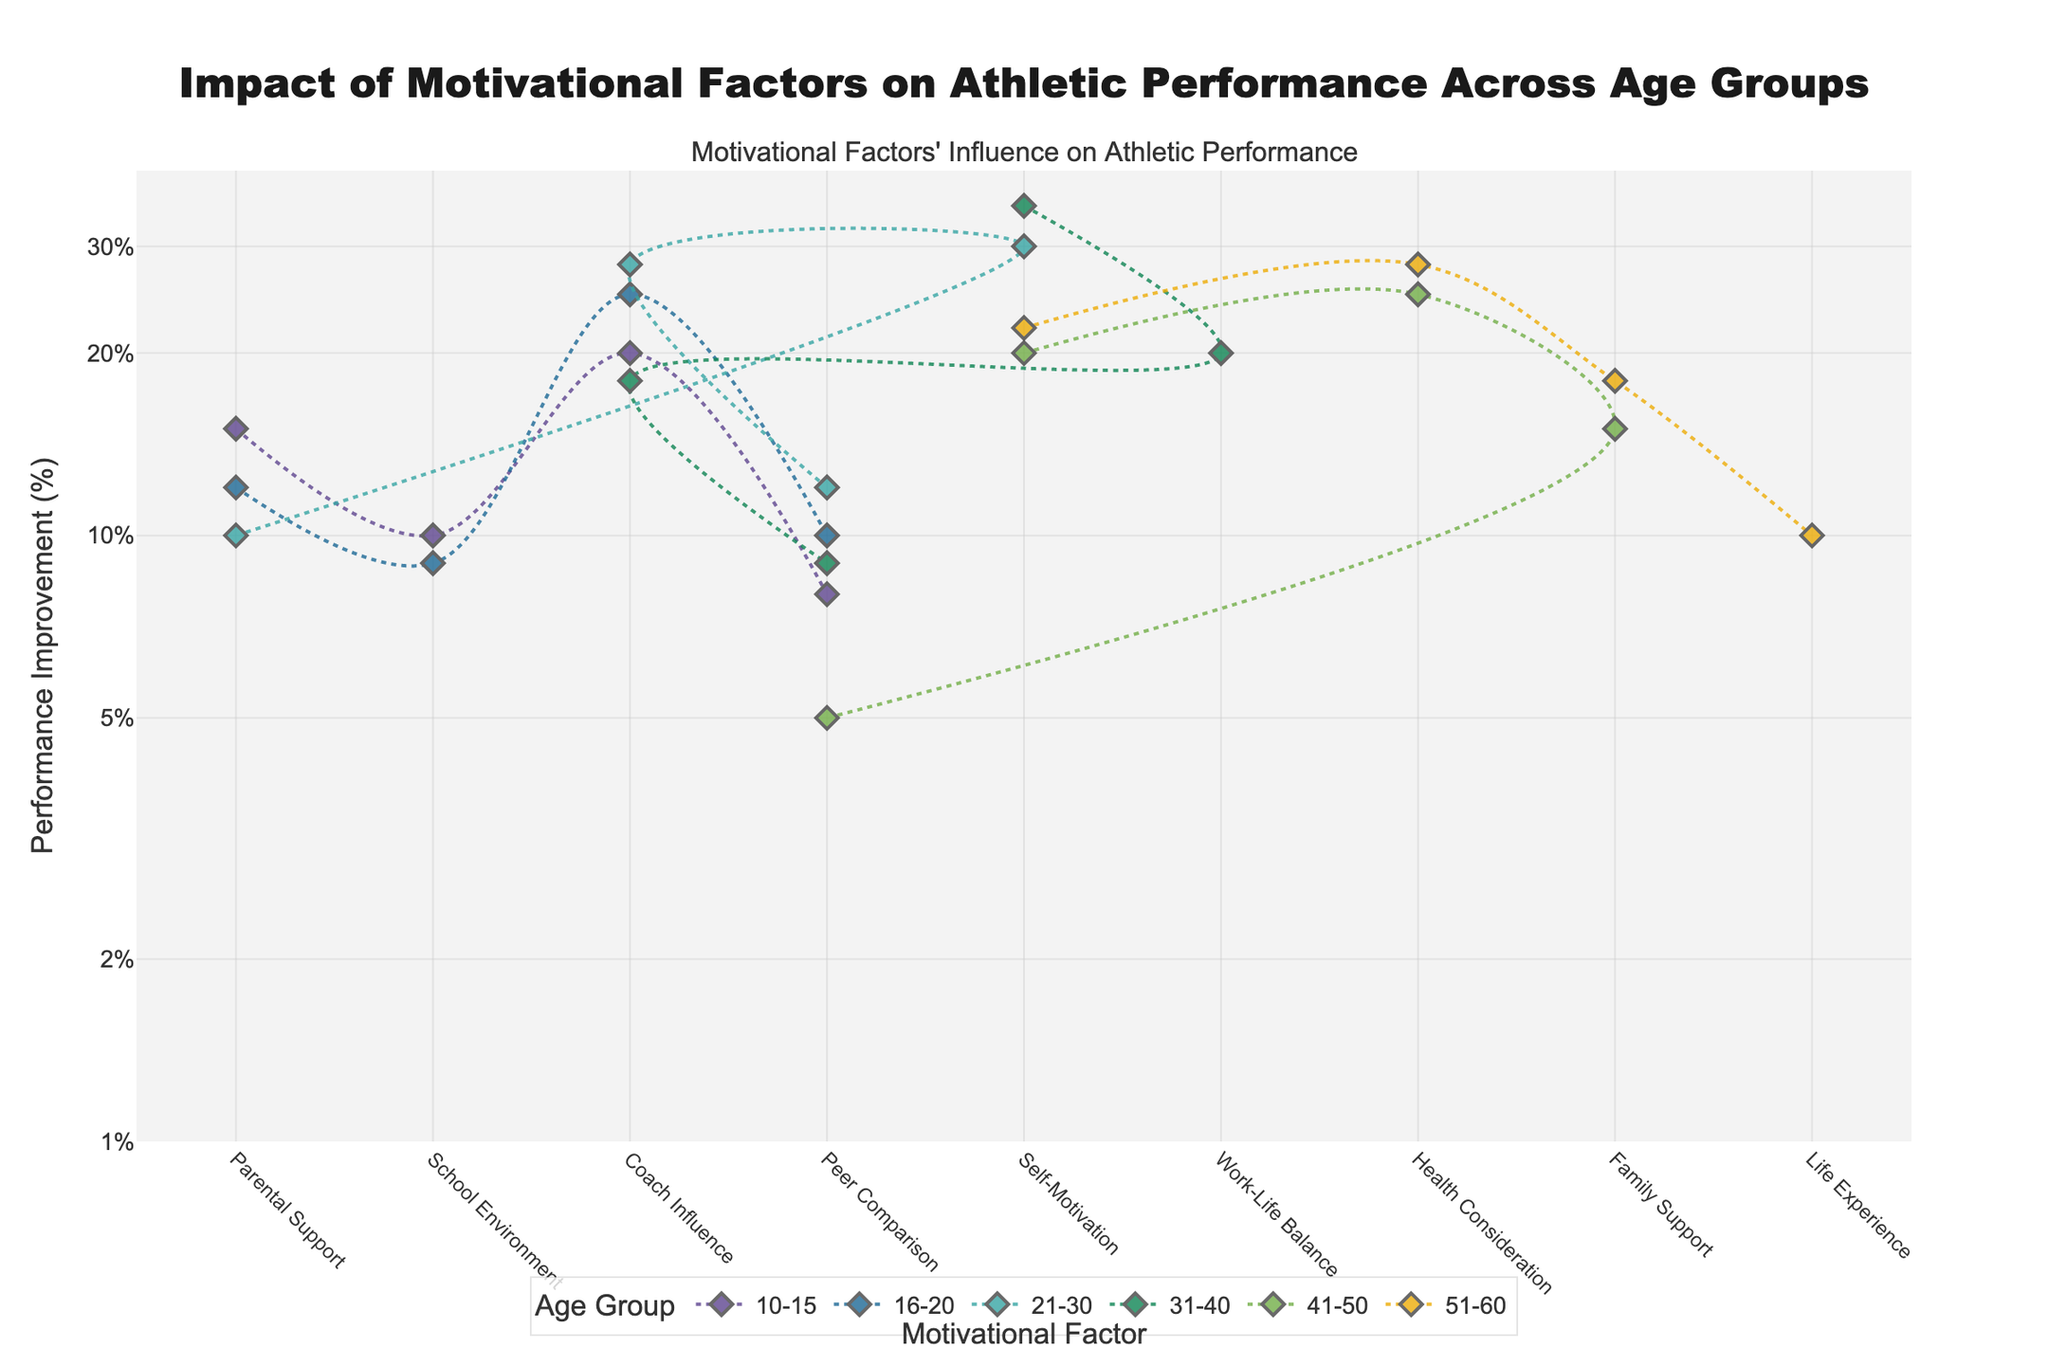How many Motivational Factors are displayed for the age group 10-15? There are four markers in the section of the plot related to the age group 10-15, each representing a different motivational factor.
Answer: 4 What is the Performance Improvement percentage for 'Coach Influence' in the 21-30 age group? Locate the diamond marker corresponding to 'Coach Influence' within the 21-30 age group section and read the y-value.
Answer: 28% Which age group shows the highest Performance Improvement for 'Self-Motivation'? Compare the Performance Improvement values for 'Self-Motivation' among the different age groups present in the plot. The highest value is in the 31-40 age group.
Answer: 31-40 What Motivational Factors are influential in the 51-60 age group, and what are their Performance Improvement percentages? Look at the markers and lines for the 51-60 age group and read the corresponding y-values for 'Self-Motivation', 'Health Consideration', 'Family Support', and 'Life Experience'.
Answer: Self-Motivation: 22%, Health Consideration: 28%, Family Support: 18%, Life Experience: 10% Compare the Performance Improvement percentages between 'Peer Comparison' across the different age groups. Which age group has the lowest and highest values, and what are they? Track the Performance Improvement values along the y-axis for 'Peer Comparison' in each age group section. The lowest value is in the 51-60 age group, and the highest value is in the 21-30 age group.
Answer: Lowest: 51-60 (5%), Highest: 21-30 (12%) What is the combined Performance Improvement percentage for 'Parental Support' in the 10-15 and 16-20 age groups? Add the Performance Improvement percentages for 'Parental Support' in the 10-15 age group (15%) and the 16-20 age group (12%).
Answer: 27% Does 'School Environment' play a role beyond the age group 16-20? Look for the presence of the 'School Environment' marker in age group sections beyond 16-20 in the plot. It does not appear in later age groups.
Answer: No Which age group shows the maximum Performance Improvement for any motivational factor, and which factor is it? Identify the highest marker on the log scale y-axis and note the age group and motivational factor associated with it.
Answer: 31-40 for 'Self-Motivation' Calculate the average Performance Improvement percentage for 'Coach Influence' across all age groups. Sum the 'Coach Influence' percentages for all groups (20 + 25 + 28 + 18) and divide by the number of groups (4).
Answer: 22.75% How does the influence of 'Health Consideration' vary between the 41-50 and 51-60 age groups? Compare the Performance Improvement values for 'Health Consideration' in the age groups 41-50 (25%) and 51-60 (28%).
Answer: 41-50: 25%, 51-60: 28% 